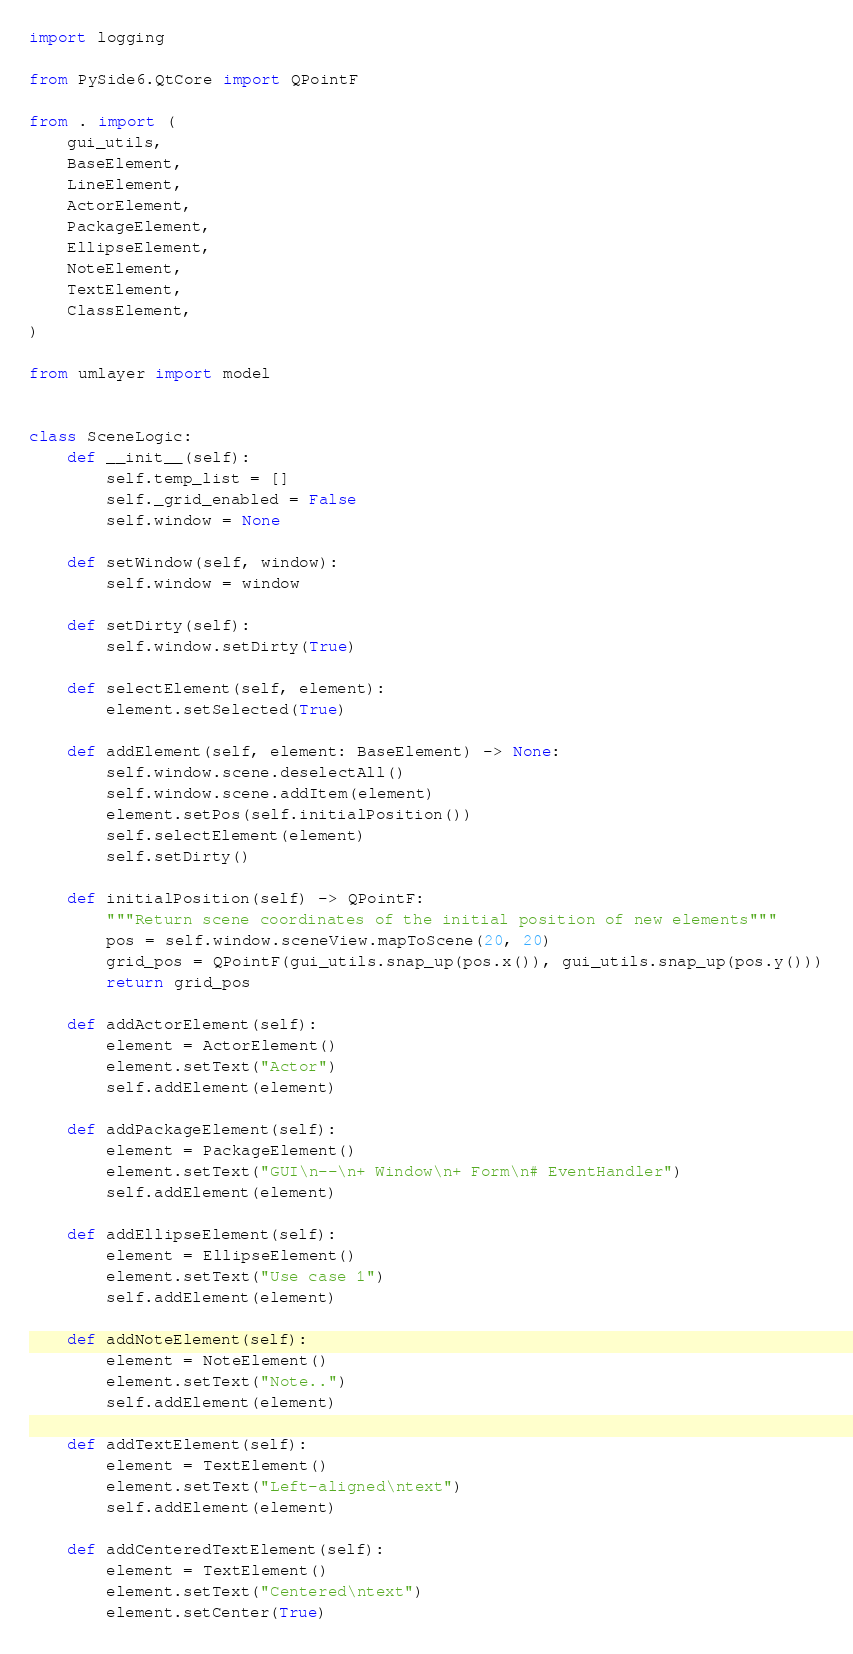<code> <loc_0><loc_0><loc_500><loc_500><_Python_>import logging

from PySide6.QtCore import QPointF

from . import (
    gui_utils,
    BaseElement,
    LineElement,
    ActorElement,
    PackageElement,
    EllipseElement,
    NoteElement,
    TextElement,
    ClassElement,
)

from umlayer import model


class SceneLogic:
    def __init__(self):
        self.temp_list = []
        self._grid_enabled = False
        self.window = None

    def setWindow(self, window):
        self.window = window

    def setDirty(self):
        self.window.setDirty(True)

    def selectElement(self, element):
        element.setSelected(True)

    def addElement(self, element: BaseElement) -> None:
        self.window.scene.deselectAll()
        self.window.scene.addItem(element)
        element.setPos(self.initialPosition())
        self.selectElement(element)
        self.setDirty()

    def initialPosition(self) -> QPointF:
        """Return scene coordinates of the initial position of new elements"""
        pos = self.window.sceneView.mapToScene(20, 20)
        grid_pos = QPointF(gui_utils.snap_up(pos.x()), gui_utils.snap_up(pos.y()))
        return grid_pos

    def addActorElement(self):
        element = ActorElement()
        element.setText("Actor")
        self.addElement(element)

    def addPackageElement(self):
        element = PackageElement()
        element.setText("GUI\n--\n+ Window\n+ Form\n# EventHandler")
        self.addElement(element)

    def addEllipseElement(self):
        element = EllipseElement()
        element.setText("Use case 1")
        self.addElement(element)

    def addNoteElement(self):
        element = NoteElement()
        element.setText("Note..")
        self.addElement(element)

    def addTextElement(self):
        element = TextElement()
        element.setText("Left-aligned\ntext")
        self.addElement(element)

    def addCenteredTextElement(self):
        element = TextElement()
        element.setText("Centered\ntext")
        element.setCenter(True)</code> 